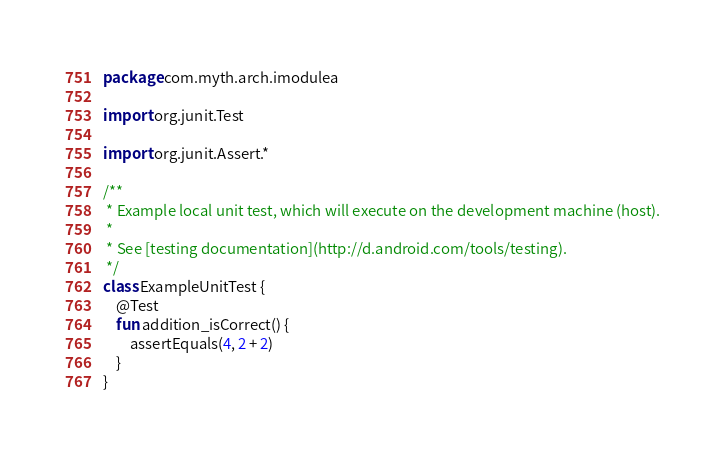<code> <loc_0><loc_0><loc_500><loc_500><_Kotlin_>package com.myth.arch.imodulea

import org.junit.Test

import org.junit.Assert.*

/**
 * Example local unit test, which will execute on the development machine (host).
 *
 * See [testing documentation](http://d.android.com/tools/testing).
 */
class ExampleUnitTest {
    @Test
    fun addition_isCorrect() {
        assertEquals(4, 2 + 2)
    }
}</code> 